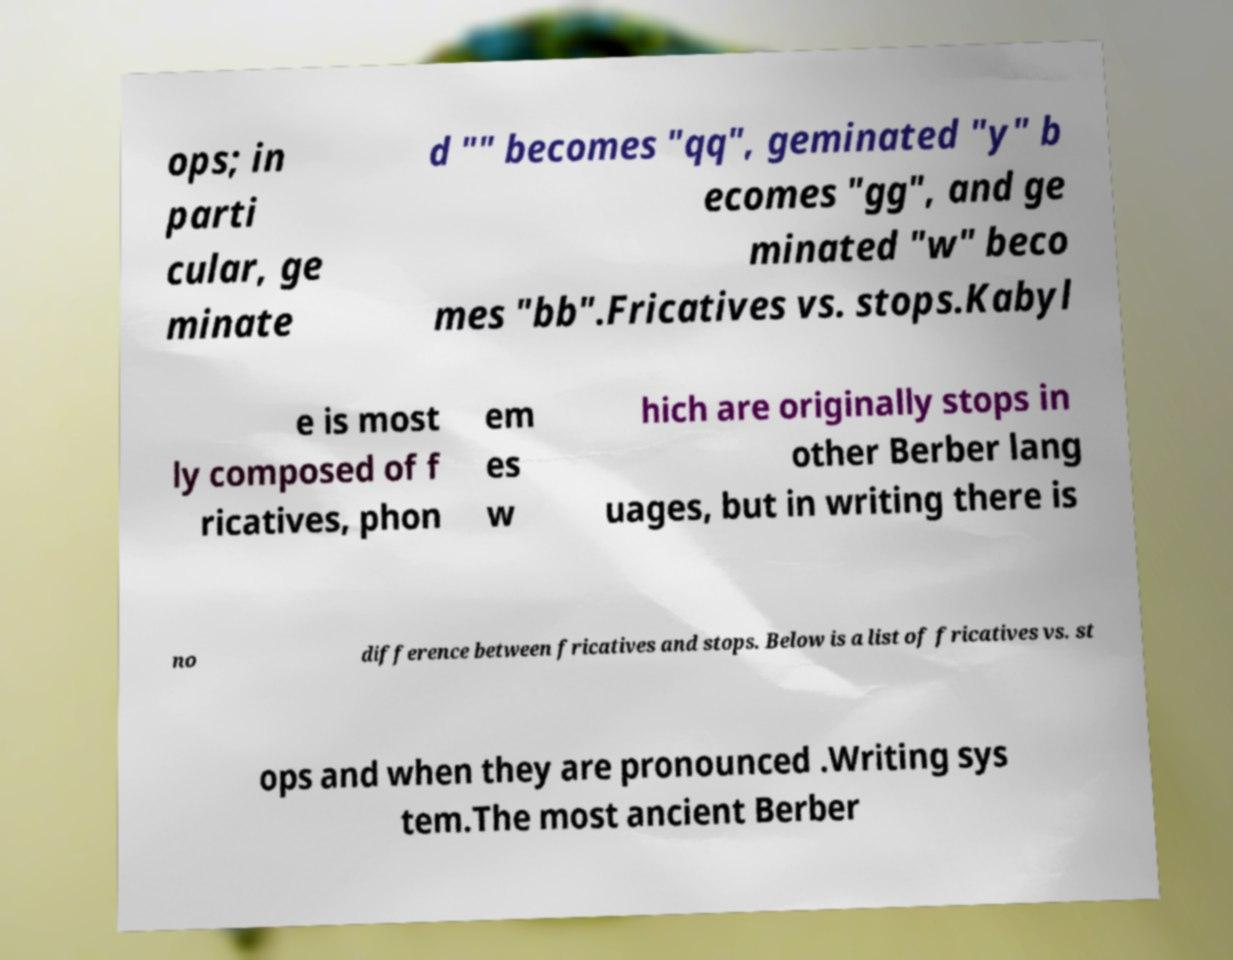Could you assist in decoding the text presented in this image and type it out clearly? ops; in parti cular, ge minate d "" becomes "qq", geminated "y" b ecomes "gg", and ge minated "w" beco mes "bb".Fricatives vs. stops.Kabyl e is most ly composed of f ricatives, phon em es w hich are originally stops in other Berber lang uages, but in writing there is no difference between fricatives and stops. Below is a list of fricatives vs. st ops and when they are pronounced .Writing sys tem.The most ancient Berber 